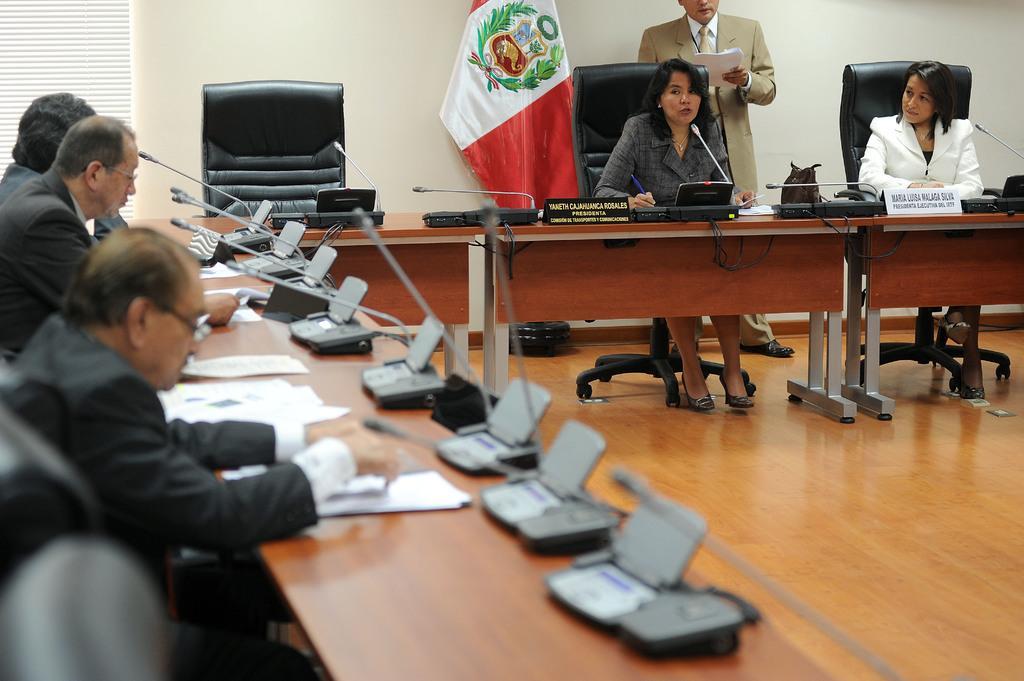In one or two sentences, can you explain what this image depicts? In this picture there is a woman who is sitting on the chair. Beside her we can see a man who is holding a papers. On the right there is another woman who is wearing white blazer. On the left there are three men wear sitting near to the table. On the table we can see a mic, papers, pens, cables and other objects. At the top there is a flag. In the top left corner there is a window blind. 